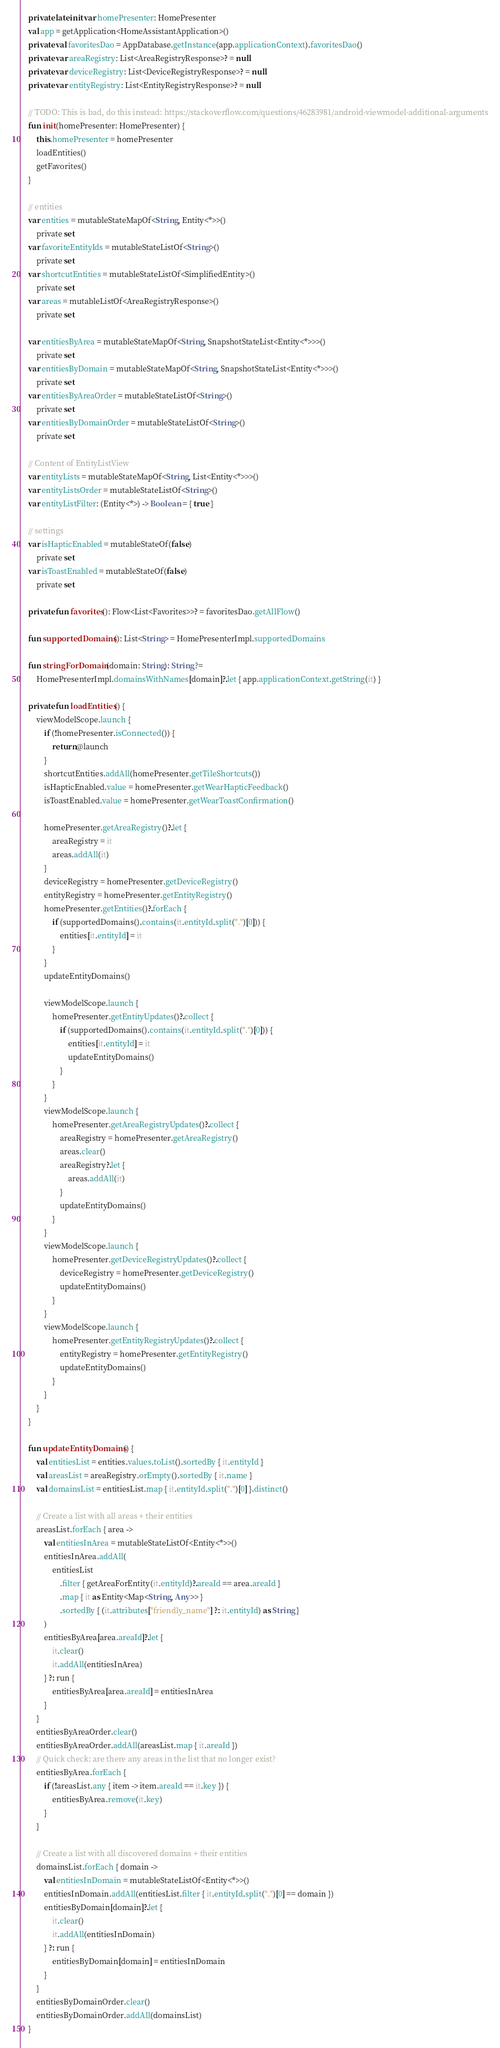Convert code to text. <code><loc_0><loc_0><loc_500><loc_500><_Kotlin_>
    private lateinit var homePresenter: HomePresenter
    val app = getApplication<HomeAssistantApplication>()
    private val favoritesDao = AppDatabase.getInstance(app.applicationContext).favoritesDao()
    private var areaRegistry: List<AreaRegistryResponse>? = null
    private var deviceRegistry: List<DeviceRegistryResponse>? = null
    private var entityRegistry: List<EntityRegistryResponse>? = null

    // TODO: This is bad, do this instead: https://stackoverflow.com/questions/46283981/android-viewmodel-additional-arguments
    fun init(homePresenter: HomePresenter) {
        this.homePresenter = homePresenter
        loadEntities()
        getFavorites()
    }

    // entities
    var entities = mutableStateMapOf<String, Entity<*>>()
        private set
    var favoriteEntityIds = mutableStateListOf<String>()
        private set
    var shortcutEntities = mutableStateListOf<SimplifiedEntity>()
        private set
    var areas = mutableListOf<AreaRegistryResponse>()
        private set

    var entitiesByArea = mutableStateMapOf<String, SnapshotStateList<Entity<*>>>()
        private set
    var entitiesByDomain = mutableStateMapOf<String, SnapshotStateList<Entity<*>>>()
        private set
    var entitiesByAreaOrder = mutableStateListOf<String>()
        private set
    var entitiesByDomainOrder = mutableStateListOf<String>()
        private set

    // Content of EntityListView
    var entityLists = mutableStateMapOf<String, List<Entity<*>>>()
    var entityListsOrder = mutableStateListOf<String>()
    var entityListFilter: (Entity<*>) -> Boolean = { true }

    // settings
    var isHapticEnabled = mutableStateOf(false)
        private set
    var isToastEnabled = mutableStateOf(false)
        private set

    private fun favorites(): Flow<List<Favorites>>? = favoritesDao.getAllFlow()

    fun supportedDomains(): List<String> = HomePresenterImpl.supportedDomains

    fun stringForDomain(domain: String): String? =
        HomePresenterImpl.domainsWithNames[domain]?.let { app.applicationContext.getString(it) }

    private fun loadEntities() {
        viewModelScope.launch {
            if (!homePresenter.isConnected()) {
                return@launch
            }
            shortcutEntities.addAll(homePresenter.getTileShortcuts())
            isHapticEnabled.value = homePresenter.getWearHapticFeedback()
            isToastEnabled.value = homePresenter.getWearToastConfirmation()

            homePresenter.getAreaRegistry()?.let {
                areaRegistry = it
                areas.addAll(it)
            }
            deviceRegistry = homePresenter.getDeviceRegistry()
            entityRegistry = homePresenter.getEntityRegistry()
            homePresenter.getEntities()?.forEach {
                if (supportedDomains().contains(it.entityId.split(".")[0])) {
                    entities[it.entityId] = it
                }
            }
            updateEntityDomains()

            viewModelScope.launch {
                homePresenter.getEntityUpdates()?.collect {
                    if (supportedDomains().contains(it.entityId.split(".")[0])) {
                        entities[it.entityId] = it
                        updateEntityDomains()
                    }
                }
            }
            viewModelScope.launch {
                homePresenter.getAreaRegistryUpdates()?.collect {
                    areaRegistry = homePresenter.getAreaRegistry()
                    areas.clear()
                    areaRegistry?.let {
                        areas.addAll(it)
                    }
                    updateEntityDomains()
                }
            }
            viewModelScope.launch {
                homePresenter.getDeviceRegistryUpdates()?.collect {
                    deviceRegistry = homePresenter.getDeviceRegistry()
                    updateEntityDomains()
                }
            }
            viewModelScope.launch {
                homePresenter.getEntityRegistryUpdates()?.collect {
                    entityRegistry = homePresenter.getEntityRegistry()
                    updateEntityDomains()
                }
            }
        }
    }

    fun updateEntityDomains() {
        val entitiesList = entities.values.toList().sortedBy { it.entityId }
        val areasList = areaRegistry.orEmpty().sortedBy { it.name }
        val domainsList = entitiesList.map { it.entityId.split(".")[0] }.distinct()

        // Create a list with all areas + their entities
        areasList.forEach { area ->
            val entitiesInArea = mutableStateListOf<Entity<*>>()
            entitiesInArea.addAll(
                entitiesList
                    .filter { getAreaForEntity(it.entityId)?.areaId == area.areaId }
                    .map { it as Entity<Map<String, Any>> }
                    .sortedBy { (it.attributes["friendly_name"] ?: it.entityId) as String }
            )
            entitiesByArea[area.areaId]?.let {
                it.clear()
                it.addAll(entitiesInArea)
            } ?: run {
                entitiesByArea[area.areaId] = entitiesInArea
            }
        }
        entitiesByAreaOrder.clear()
        entitiesByAreaOrder.addAll(areasList.map { it.areaId })
        // Quick check: are there any areas in the list that no longer exist?
        entitiesByArea.forEach {
            if (!areasList.any { item -> item.areaId == it.key }) {
                entitiesByArea.remove(it.key)
            }
        }

        // Create a list with all discovered domains + their entities
        domainsList.forEach { domain ->
            val entitiesInDomain = mutableStateListOf<Entity<*>>()
            entitiesInDomain.addAll(entitiesList.filter { it.entityId.split(".")[0] == domain })
            entitiesByDomain[domain]?.let {
                it.clear()
                it.addAll(entitiesInDomain)
            } ?: run {
                entitiesByDomain[domain] = entitiesInDomain
            }
        }
        entitiesByDomainOrder.clear()
        entitiesByDomainOrder.addAll(domainsList)
    }
</code> 